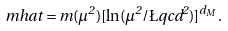Convert formula to latex. <formula><loc_0><loc_0><loc_500><loc_500>\ m h a t = m ( \mu ^ { 2 } ) [ \ln ( \mu ^ { 2 } / \L q c d ^ { 2 } ) ] ^ { d _ { M } } .</formula> 